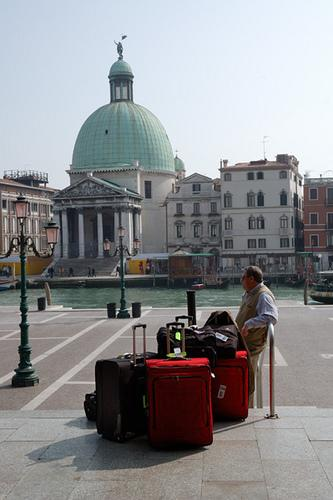What mode of transport did this person recently take advantage of? Please explain your reasoning. air travel. They have many suitcases which would not fit into the other modes of transportation, and luggage tags which don't exist for the other modes of transportation. 